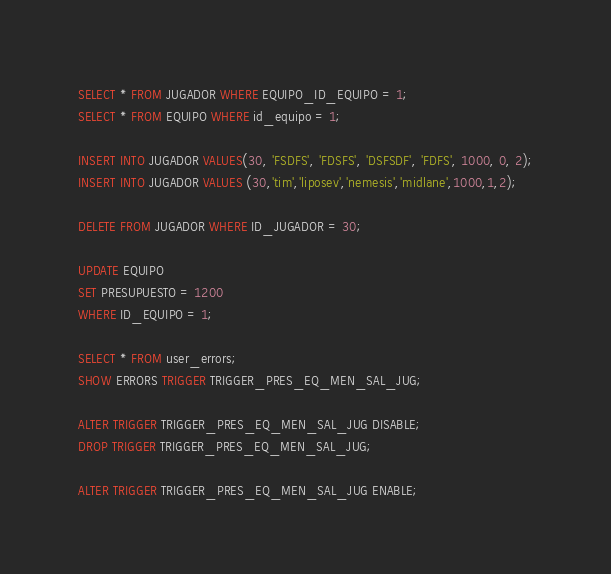<code> <loc_0><loc_0><loc_500><loc_500><_SQL_>SELECT * FROM JUGADOR WHERE EQUIPO_ID_EQUIPO = 1;
SELECT * FROM EQUIPO WHERE id_equipo = 1;

INSERT INTO JUGADOR VALUES(30, 'FSDFS', 'FDSFS', 'DSFSDF', 'FDFS', 1000, 0, 2);
INSERT INTO JUGADOR VALUES (30,'tim','liposev','nemesis','midlane',1000,1,2);

DELETE FROM JUGADOR WHERE ID_JUGADOR = 30;

UPDATE EQUIPO
SET PRESUPUESTO = 1200
WHERE ID_EQUIPO = 1;

SELECT * FROM user_errors;
SHOW ERRORS TRIGGER TRIGGER_PRES_EQ_MEN_SAL_JUG;

ALTER TRIGGER TRIGGER_PRES_EQ_MEN_SAL_JUG DISABLE;
DROP TRIGGER TRIGGER_PRES_EQ_MEN_SAL_JUG;

ALTER TRIGGER TRIGGER_PRES_EQ_MEN_SAL_JUG ENABLE;


</code> 